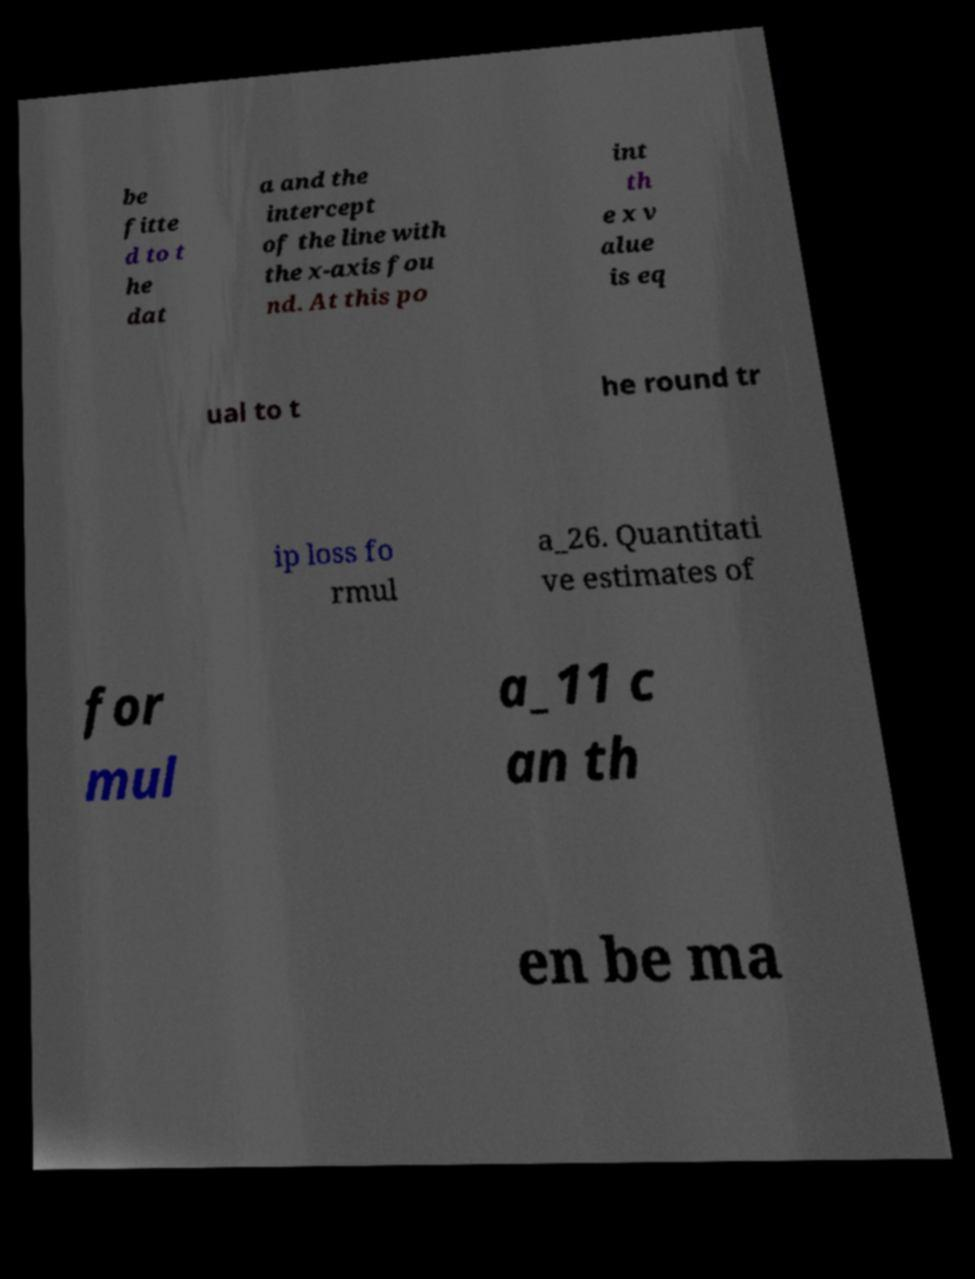There's text embedded in this image that I need extracted. Can you transcribe it verbatim? be fitte d to t he dat a and the intercept of the line with the x-axis fou nd. At this po int th e x v alue is eq ual to t he round tr ip loss fo rmul a_26. Quantitati ve estimates of for mul a_11 c an th en be ma 